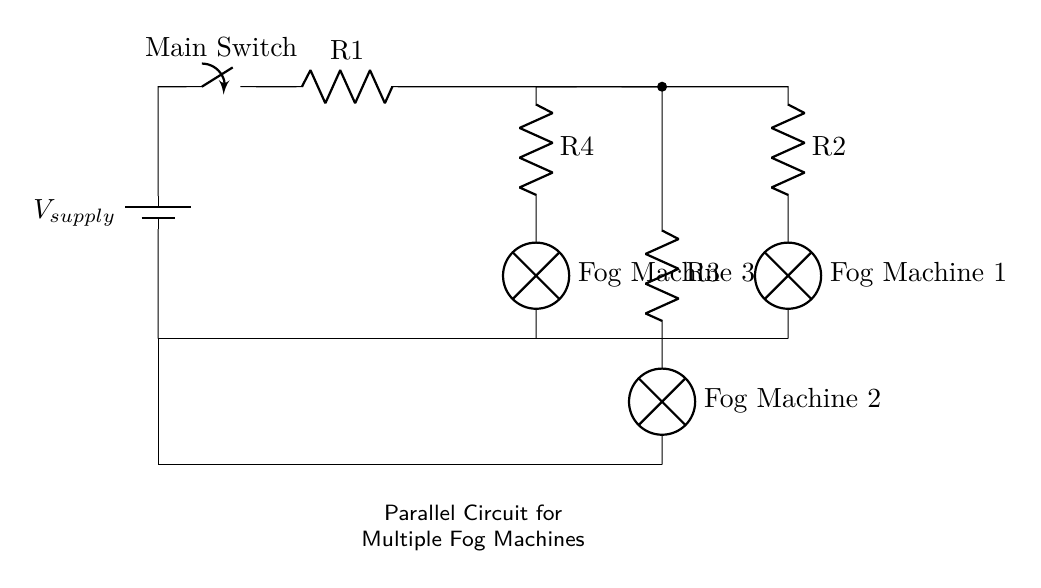What is the voltage source in this circuit? The voltage source is labeled as V_supply, indicating the source of electrical power for the circuit.
Answer: V_supply How many fog machines are present in the circuit? The circuit diagram clearly shows three separate fog machines connected in parallel to the power source.
Answer: 3 What type of circuit configuration is used for the fog machines? The circuit is designed in a parallel configuration, as all components are connected across common voltage points, allowing independent operation.
Answer: Parallel What is the function of the main switch in this circuit? The main switch controls the flow of current from the voltage source to the entire circuit, enabling or disabling all connected fog machines simultaneously.
Answer: Control power What will happen if one fog machine fails? Since the fog machines are connected in parallel, if one fails, the others will continue to operate unaffected, ensuring that not all machines are impacted.
Answer: Others continue operating Which component acts as a current limiting resistor in the circuit? The circuit diagram includes resistors R1, R2, R3, and R4, which help manage the current flowing to each fog machine.
Answer: R1, R2, R3, R4 